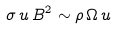Convert formula to latex. <formula><loc_0><loc_0><loc_500><loc_500>\sigma \, u \, B ^ { 2 } \sim \rho \, \Omega \, u</formula> 